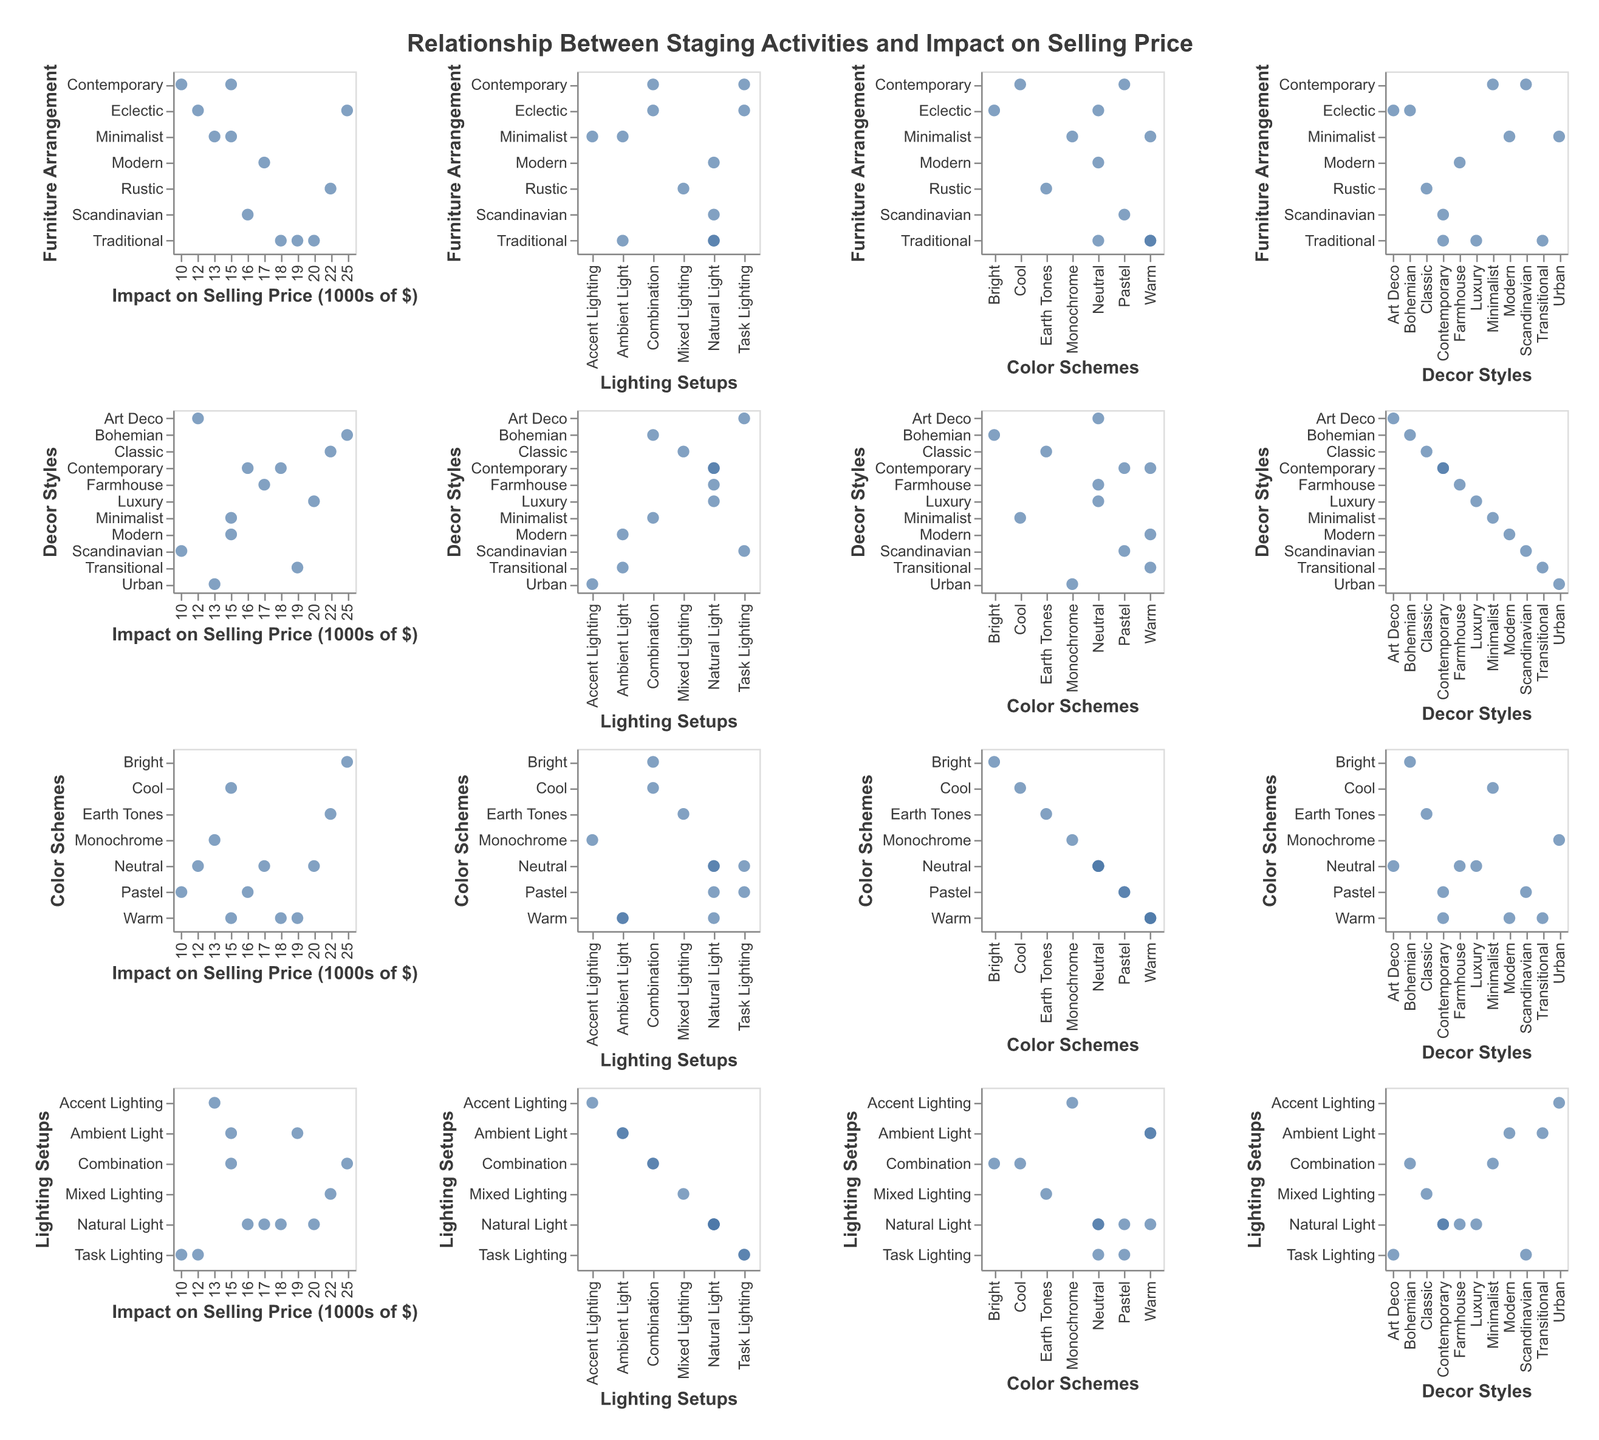What is the title of the scatter plot matrix? The title of the scatter plot matrix is typically displayed at the top of the figure and summarizes what the entire figure is about. In this case, it reads "Relationship Between Staging Activities and Impact on Selling Price".
Answer: Relationship Between Staging Activities and Impact on Selling Price What is the range of the "Impact on Selling Price" axis? The "Impact on Selling Price" axis ranges from the lowest to the highest values of "Impact on Selling Price (1000s of $)" present in the data. Observing the data points, the range is between $10,000 and $25,000.
Answer: $10,000 to $25,000 Which decor style has the highest impact on selling price? To find the answer, look for the highest value on the "Impact on Selling Price (1000s of $)" axis and see which decor style it correlates to. In this figure, the highest selling price impact is $25,000, which corresponds to the Bohemian decor style.
Answer: Bohemian How many data points represent the "Traditional" furniture arrangement style? Count the number of points labeled with "Traditional" under the "Furniture Arrangement" category across the figure. There are three data points with "Traditional" arrangement.
Answer: 3 Which color scheme appears most frequently? By observing the plot matrix, identify the color scheme that has the highest number of points across all subplots. "Warm" and "Neutral" each appear three times. To settle the tie: ensure "Warm" is indeed matched with the correct axes, confirming they appear most frequently.
Answer: Warm and Neutral (tie) Is there more than one lighting setup that yields an "Impact on Selling Price" of $20,000 or higher? Observe the axis for "Lighting Setups" and find the corresponding points on the "Impact on Selling Price (1000s of $)" axis for values $20,000 or higher. Only "Natural Light" reaches these high values.
Answer: No Which combination of staging activities resulted in the lowest impact on selling price, and what was its value? Look for the lowest value on the "Impact on Selling Price (1000s of $)" axis, which is $10,000. Check the corresponding categories for this data point. It matches with "Contemporary" furniture, "Scandinavian" decor, "Pastel" color schemes, and "Task Lighting".
Answer: Contemporary, Scandinavian, Pastel, Task Lighting, $10,000 Which lighting setup is associated with the highest average impact on selling price? Calculate the average impact on selling price for each lighting setup. Sum these values and divide by the count for each category. "Mixed Lighting": $22,000 (1 point); "Ambient Light": (15,000 + 19,000) / 2 = $17,000; "Accent Lighting": $13,000 (1); "Task Lighting": (10,000 + 12,000) / 2 = $11,000; "Natural Light": (20,000 + 18,000 + 17,000 + 16,000) / 4 = $17,750; "Combination": (25,000 + 15,000) / 2 = $20,000. "Combination" setup has the highest average.
Answer: Combination What is the impact on selling price for "Rustic" furniture arrangement? Check the data points for "Rustic" under "Furniture Arrangement" and note the corresponding "Impact on Selling Price". "Rustic" has one point with an impact of $22,000.
Answer: $22,000 